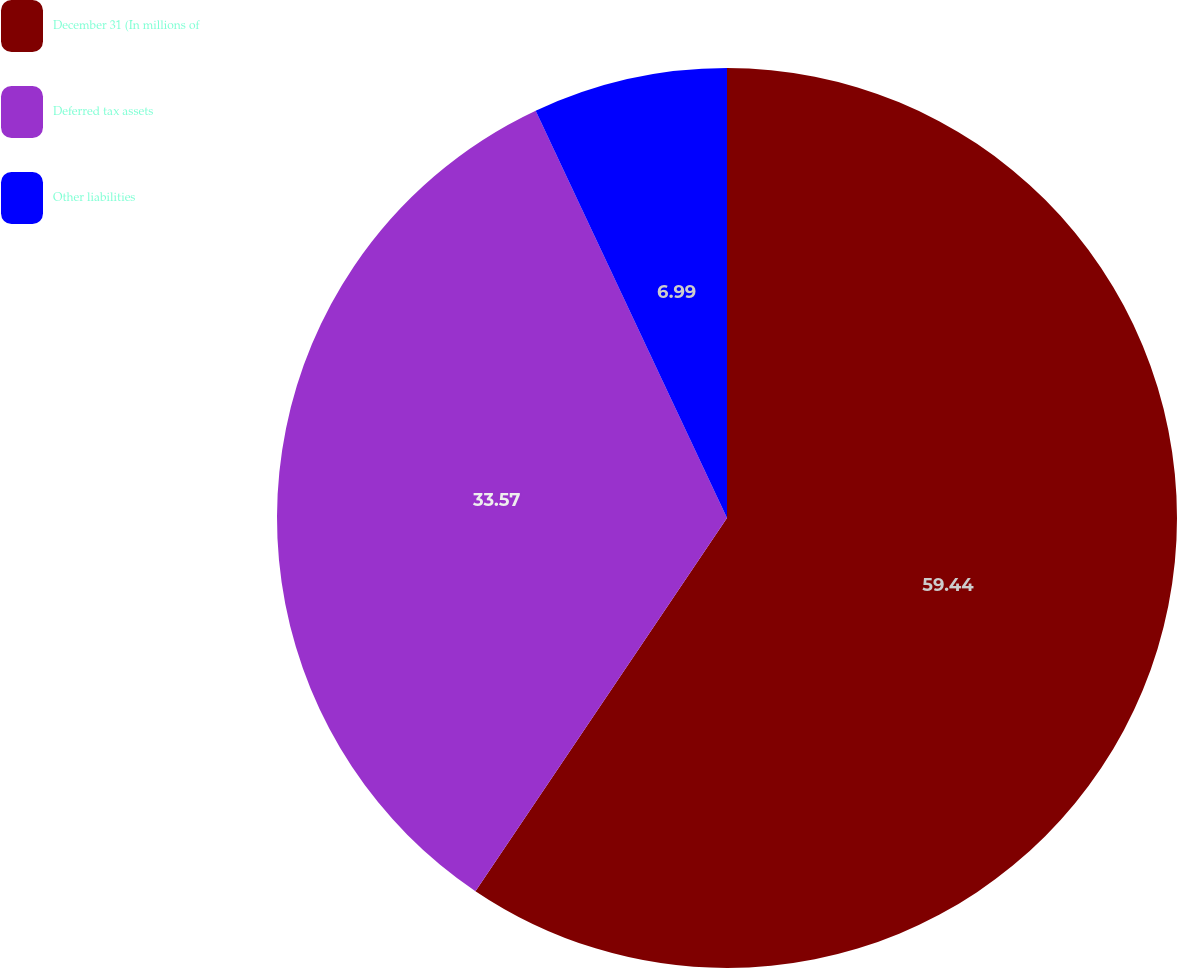Convert chart to OTSL. <chart><loc_0><loc_0><loc_500><loc_500><pie_chart><fcel>December 31 (In millions of<fcel>Deferred tax assets<fcel>Other liabilities<nl><fcel>59.44%<fcel>33.57%<fcel>6.99%<nl></chart> 